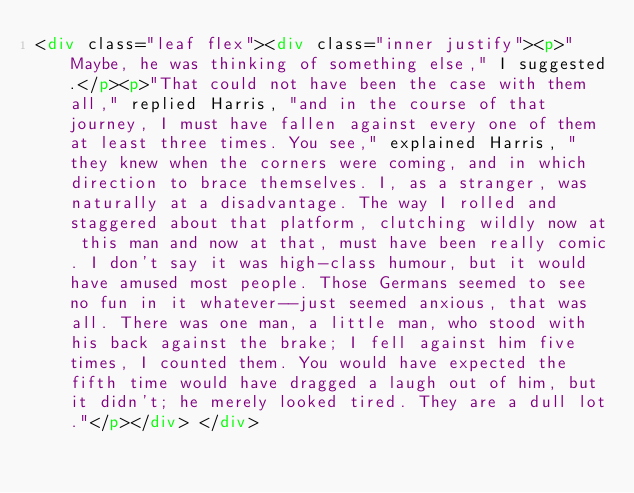<code> <loc_0><loc_0><loc_500><loc_500><_HTML_><div class="leaf flex"><div class="inner justify"><p>"Maybe, he was thinking of something else," I suggested.</p><p>"That could not have been the case with them all," replied Harris, "and in the course of that journey, I must have fallen against every one of them at least three times. You see," explained Harris, "they knew when the corners were coming, and in which direction to brace themselves. I, as a stranger, was naturally at a disadvantage. The way I rolled and staggered about that platform, clutching wildly now at this man and now at that, must have been really comic. I don't say it was high-class humour, but it would have amused most people. Those Germans seemed to see no fun in it whatever--just seemed anxious, that was all. There was one man, a little man, who stood with his back against the brake; I fell against him five times, I counted them. You would have expected the fifth time would have dragged a laugh out of him, but it didn't; he merely looked tired. They are a dull lot."</p></div> </div></code> 